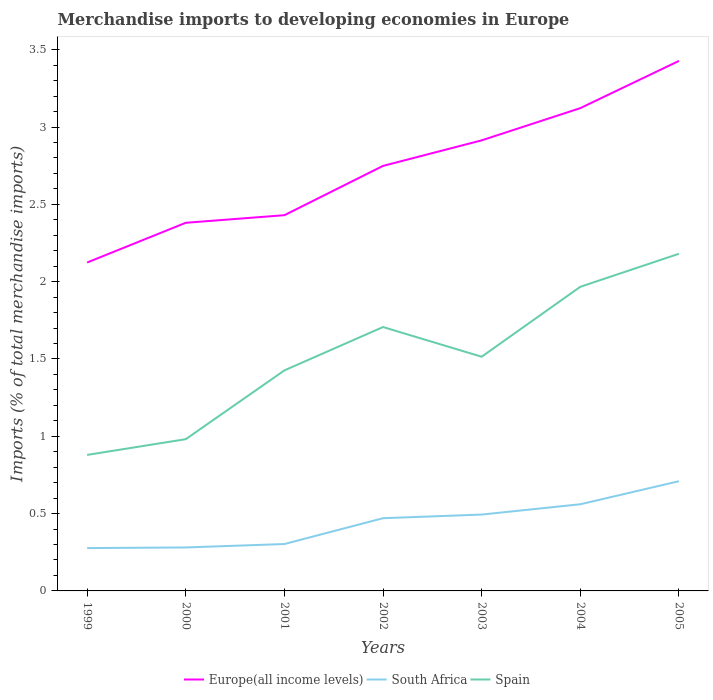How many different coloured lines are there?
Provide a short and direct response. 3. Across all years, what is the maximum percentage total merchandise imports in South Africa?
Your answer should be compact. 0.28. In which year was the percentage total merchandise imports in Spain maximum?
Give a very brief answer. 1999. What is the total percentage total merchandise imports in South Africa in the graph?
Keep it short and to the point. -0.15. What is the difference between the highest and the second highest percentage total merchandise imports in South Africa?
Give a very brief answer. 0.43. How many years are there in the graph?
Your answer should be very brief. 7. Does the graph contain any zero values?
Offer a terse response. No. Where does the legend appear in the graph?
Ensure brevity in your answer.  Bottom center. How many legend labels are there?
Provide a short and direct response. 3. What is the title of the graph?
Offer a terse response. Merchandise imports to developing economies in Europe. What is the label or title of the X-axis?
Give a very brief answer. Years. What is the label or title of the Y-axis?
Make the answer very short. Imports (% of total merchandise imports). What is the Imports (% of total merchandise imports) in Europe(all income levels) in 1999?
Your answer should be compact. 2.12. What is the Imports (% of total merchandise imports) of South Africa in 1999?
Provide a succinct answer. 0.28. What is the Imports (% of total merchandise imports) in Spain in 1999?
Your response must be concise. 0.88. What is the Imports (% of total merchandise imports) of Europe(all income levels) in 2000?
Your answer should be compact. 2.38. What is the Imports (% of total merchandise imports) in South Africa in 2000?
Offer a very short reply. 0.28. What is the Imports (% of total merchandise imports) in Spain in 2000?
Offer a very short reply. 0.98. What is the Imports (% of total merchandise imports) in Europe(all income levels) in 2001?
Give a very brief answer. 2.43. What is the Imports (% of total merchandise imports) of South Africa in 2001?
Keep it short and to the point. 0.3. What is the Imports (% of total merchandise imports) of Spain in 2001?
Keep it short and to the point. 1.43. What is the Imports (% of total merchandise imports) of Europe(all income levels) in 2002?
Your answer should be very brief. 2.75. What is the Imports (% of total merchandise imports) of South Africa in 2002?
Provide a succinct answer. 0.47. What is the Imports (% of total merchandise imports) in Spain in 2002?
Your answer should be very brief. 1.71. What is the Imports (% of total merchandise imports) of Europe(all income levels) in 2003?
Your response must be concise. 2.91. What is the Imports (% of total merchandise imports) in South Africa in 2003?
Provide a succinct answer. 0.49. What is the Imports (% of total merchandise imports) in Spain in 2003?
Your response must be concise. 1.51. What is the Imports (% of total merchandise imports) in Europe(all income levels) in 2004?
Offer a very short reply. 3.12. What is the Imports (% of total merchandise imports) of South Africa in 2004?
Your response must be concise. 0.56. What is the Imports (% of total merchandise imports) in Spain in 2004?
Keep it short and to the point. 1.97. What is the Imports (% of total merchandise imports) of Europe(all income levels) in 2005?
Make the answer very short. 3.43. What is the Imports (% of total merchandise imports) in South Africa in 2005?
Make the answer very short. 0.71. What is the Imports (% of total merchandise imports) of Spain in 2005?
Give a very brief answer. 2.18. Across all years, what is the maximum Imports (% of total merchandise imports) in Europe(all income levels)?
Keep it short and to the point. 3.43. Across all years, what is the maximum Imports (% of total merchandise imports) of South Africa?
Your answer should be compact. 0.71. Across all years, what is the maximum Imports (% of total merchandise imports) of Spain?
Your response must be concise. 2.18. Across all years, what is the minimum Imports (% of total merchandise imports) in Europe(all income levels)?
Provide a short and direct response. 2.12. Across all years, what is the minimum Imports (% of total merchandise imports) of South Africa?
Keep it short and to the point. 0.28. Across all years, what is the minimum Imports (% of total merchandise imports) of Spain?
Offer a terse response. 0.88. What is the total Imports (% of total merchandise imports) of Europe(all income levels) in the graph?
Provide a succinct answer. 19.15. What is the total Imports (% of total merchandise imports) in South Africa in the graph?
Your answer should be very brief. 3.1. What is the total Imports (% of total merchandise imports) of Spain in the graph?
Your answer should be compact. 10.66. What is the difference between the Imports (% of total merchandise imports) in Europe(all income levels) in 1999 and that in 2000?
Provide a short and direct response. -0.26. What is the difference between the Imports (% of total merchandise imports) in South Africa in 1999 and that in 2000?
Keep it short and to the point. -0. What is the difference between the Imports (% of total merchandise imports) of Spain in 1999 and that in 2000?
Offer a very short reply. -0.1. What is the difference between the Imports (% of total merchandise imports) of Europe(all income levels) in 1999 and that in 2001?
Give a very brief answer. -0.31. What is the difference between the Imports (% of total merchandise imports) of South Africa in 1999 and that in 2001?
Offer a terse response. -0.03. What is the difference between the Imports (% of total merchandise imports) in Spain in 1999 and that in 2001?
Your answer should be compact. -0.55. What is the difference between the Imports (% of total merchandise imports) in Europe(all income levels) in 1999 and that in 2002?
Make the answer very short. -0.62. What is the difference between the Imports (% of total merchandise imports) in South Africa in 1999 and that in 2002?
Your response must be concise. -0.19. What is the difference between the Imports (% of total merchandise imports) of Spain in 1999 and that in 2002?
Provide a short and direct response. -0.83. What is the difference between the Imports (% of total merchandise imports) of Europe(all income levels) in 1999 and that in 2003?
Make the answer very short. -0.79. What is the difference between the Imports (% of total merchandise imports) of South Africa in 1999 and that in 2003?
Keep it short and to the point. -0.22. What is the difference between the Imports (% of total merchandise imports) in Spain in 1999 and that in 2003?
Your response must be concise. -0.64. What is the difference between the Imports (% of total merchandise imports) in Europe(all income levels) in 1999 and that in 2004?
Keep it short and to the point. -1. What is the difference between the Imports (% of total merchandise imports) in South Africa in 1999 and that in 2004?
Ensure brevity in your answer.  -0.28. What is the difference between the Imports (% of total merchandise imports) in Spain in 1999 and that in 2004?
Provide a succinct answer. -1.09. What is the difference between the Imports (% of total merchandise imports) in Europe(all income levels) in 1999 and that in 2005?
Keep it short and to the point. -1.3. What is the difference between the Imports (% of total merchandise imports) in South Africa in 1999 and that in 2005?
Give a very brief answer. -0.43. What is the difference between the Imports (% of total merchandise imports) in Spain in 1999 and that in 2005?
Offer a terse response. -1.3. What is the difference between the Imports (% of total merchandise imports) of Europe(all income levels) in 2000 and that in 2001?
Provide a short and direct response. -0.05. What is the difference between the Imports (% of total merchandise imports) of South Africa in 2000 and that in 2001?
Your answer should be very brief. -0.02. What is the difference between the Imports (% of total merchandise imports) of Spain in 2000 and that in 2001?
Your response must be concise. -0.44. What is the difference between the Imports (% of total merchandise imports) in Europe(all income levels) in 2000 and that in 2002?
Offer a very short reply. -0.37. What is the difference between the Imports (% of total merchandise imports) of South Africa in 2000 and that in 2002?
Provide a short and direct response. -0.19. What is the difference between the Imports (% of total merchandise imports) of Spain in 2000 and that in 2002?
Your answer should be compact. -0.73. What is the difference between the Imports (% of total merchandise imports) of Europe(all income levels) in 2000 and that in 2003?
Make the answer very short. -0.53. What is the difference between the Imports (% of total merchandise imports) of South Africa in 2000 and that in 2003?
Your response must be concise. -0.21. What is the difference between the Imports (% of total merchandise imports) of Spain in 2000 and that in 2003?
Your answer should be compact. -0.53. What is the difference between the Imports (% of total merchandise imports) in Europe(all income levels) in 2000 and that in 2004?
Offer a terse response. -0.74. What is the difference between the Imports (% of total merchandise imports) of South Africa in 2000 and that in 2004?
Offer a terse response. -0.28. What is the difference between the Imports (% of total merchandise imports) in Spain in 2000 and that in 2004?
Your response must be concise. -0.99. What is the difference between the Imports (% of total merchandise imports) in Europe(all income levels) in 2000 and that in 2005?
Give a very brief answer. -1.05. What is the difference between the Imports (% of total merchandise imports) in South Africa in 2000 and that in 2005?
Give a very brief answer. -0.43. What is the difference between the Imports (% of total merchandise imports) in Spain in 2000 and that in 2005?
Your answer should be compact. -1.2. What is the difference between the Imports (% of total merchandise imports) in Europe(all income levels) in 2001 and that in 2002?
Offer a very short reply. -0.32. What is the difference between the Imports (% of total merchandise imports) in South Africa in 2001 and that in 2002?
Provide a short and direct response. -0.17. What is the difference between the Imports (% of total merchandise imports) in Spain in 2001 and that in 2002?
Make the answer very short. -0.28. What is the difference between the Imports (% of total merchandise imports) of Europe(all income levels) in 2001 and that in 2003?
Your answer should be compact. -0.48. What is the difference between the Imports (% of total merchandise imports) of South Africa in 2001 and that in 2003?
Your response must be concise. -0.19. What is the difference between the Imports (% of total merchandise imports) of Spain in 2001 and that in 2003?
Make the answer very short. -0.09. What is the difference between the Imports (% of total merchandise imports) of Europe(all income levels) in 2001 and that in 2004?
Provide a succinct answer. -0.69. What is the difference between the Imports (% of total merchandise imports) in South Africa in 2001 and that in 2004?
Provide a short and direct response. -0.26. What is the difference between the Imports (% of total merchandise imports) of Spain in 2001 and that in 2004?
Ensure brevity in your answer.  -0.54. What is the difference between the Imports (% of total merchandise imports) of Europe(all income levels) in 2001 and that in 2005?
Your answer should be very brief. -1. What is the difference between the Imports (% of total merchandise imports) of South Africa in 2001 and that in 2005?
Provide a short and direct response. -0.41. What is the difference between the Imports (% of total merchandise imports) in Spain in 2001 and that in 2005?
Keep it short and to the point. -0.75. What is the difference between the Imports (% of total merchandise imports) of Europe(all income levels) in 2002 and that in 2003?
Your answer should be very brief. -0.17. What is the difference between the Imports (% of total merchandise imports) in South Africa in 2002 and that in 2003?
Your response must be concise. -0.02. What is the difference between the Imports (% of total merchandise imports) of Spain in 2002 and that in 2003?
Offer a terse response. 0.19. What is the difference between the Imports (% of total merchandise imports) in Europe(all income levels) in 2002 and that in 2004?
Your response must be concise. -0.37. What is the difference between the Imports (% of total merchandise imports) in South Africa in 2002 and that in 2004?
Ensure brevity in your answer.  -0.09. What is the difference between the Imports (% of total merchandise imports) in Spain in 2002 and that in 2004?
Your answer should be compact. -0.26. What is the difference between the Imports (% of total merchandise imports) in Europe(all income levels) in 2002 and that in 2005?
Your response must be concise. -0.68. What is the difference between the Imports (% of total merchandise imports) in South Africa in 2002 and that in 2005?
Your response must be concise. -0.24. What is the difference between the Imports (% of total merchandise imports) in Spain in 2002 and that in 2005?
Your response must be concise. -0.47. What is the difference between the Imports (% of total merchandise imports) in Europe(all income levels) in 2003 and that in 2004?
Keep it short and to the point. -0.21. What is the difference between the Imports (% of total merchandise imports) in South Africa in 2003 and that in 2004?
Your response must be concise. -0.07. What is the difference between the Imports (% of total merchandise imports) in Spain in 2003 and that in 2004?
Your response must be concise. -0.45. What is the difference between the Imports (% of total merchandise imports) in Europe(all income levels) in 2003 and that in 2005?
Provide a short and direct response. -0.51. What is the difference between the Imports (% of total merchandise imports) of South Africa in 2003 and that in 2005?
Provide a short and direct response. -0.22. What is the difference between the Imports (% of total merchandise imports) in Spain in 2003 and that in 2005?
Make the answer very short. -0.67. What is the difference between the Imports (% of total merchandise imports) in Europe(all income levels) in 2004 and that in 2005?
Your response must be concise. -0.31. What is the difference between the Imports (% of total merchandise imports) of South Africa in 2004 and that in 2005?
Give a very brief answer. -0.15. What is the difference between the Imports (% of total merchandise imports) of Spain in 2004 and that in 2005?
Offer a very short reply. -0.21. What is the difference between the Imports (% of total merchandise imports) of Europe(all income levels) in 1999 and the Imports (% of total merchandise imports) of South Africa in 2000?
Your answer should be very brief. 1.84. What is the difference between the Imports (% of total merchandise imports) in Europe(all income levels) in 1999 and the Imports (% of total merchandise imports) in Spain in 2000?
Provide a short and direct response. 1.14. What is the difference between the Imports (% of total merchandise imports) of South Africa in 1999 and the Imports (% of total merchandise imports) of Spain in 2000?
Make the answer very short. -0.7. What is the difference between the Imports (% of total merchandise imports) of Europe(all income levels) in 1999 and the Imports (% of total merchandise imports) of South Africa in 2001?
Your response must be concise. 1.82. What is the difference between the Imports (% of total merchandise imports) of Europe(all income levels) in 1999 and the Imports (% of total merchandise imports) of Spain in 2001?
Provide a succinct answer. 0.7. What is the difference between the Imports (% of total merchandise imports) of South Africa in 1999 and the Imports (% of total merchandise imports) of Spain in 2001?
Ensure brevity in your answer.  -1.15. What is the difference between the Imports (% of total merchandise imports) in Europe(all income levels) in 1999 and the Imports (% of total merchandise imports) in South Africa in 2002?
Offer a very short reply. 1.65. What is the difference between the Imports (% of total merchandise imports) in Europe(all income levels) in 1999 and the Imports (% of total merchandise imports) in Spain in 2002?
Ensure brevity in your answer.  0.42. What is the difference between the Imports (% of total merchandise imports) in South Africa in 1999 and the Imports (% of total merchandise imports) in Spain in 2002?
Keep it short and to the point. -1.43. What is the difference between the Imports (% of total merchandise imports) of Europe(all income levels) in 1999 and the Imports (% of total merchandise imports) of South Africa in 2003?
Provide a short and direct response. 1.63. What is the difference between the Imports (% of total merchandise imports) in Europe(all income levels) in 1999 and the Imports (% of total merchandise imports) in Spain in 2003?
Offer a very short reply. 0.61. What is the difference between the Imports (% of total merchandise imports) in South Africa in 1999 and the Imports (% of total merchandise imports) in Spain in 2003?
Your answer should be compact. -1.24. What is the difference between the Imports (% of total merchandise imports) of Europe(all income levels) in 1999 and the Imports (% of total merchandise imports) of South Africa in 2004?
Provide a short and direct response. 1.56. What is the difference between the Imports (% of total merchandise imports) of Europe(all income levels) in 1999 and the Imports (% of total merchandise imports) of Spain in 2004?
Your response must be concise. 0.16. What is the difference between the Imports (% of total merchandise imports) in South Africa in 1999 and the Imports (% of total merchandise imports) in Spain in 2004?
Provide a succinct answer. -1.69. What is the difference between the Imports (% of total merchandise imports) in Europe(all income levels) in 1999 and the Imports (% of total merchandise imports) in South Africa in 2005?
Ensure brevity in your answer.  1.41. What is the difference between the Imports (% of total merchandise imports) of Europe(all income levels) in 1999 and the Imports (% of total merchandise imports) of Spain in 2005?
Provide a short and direct response. -0.06. What is the difference between the Imports (% of total merchandise imports) of South Africa in 1999 and the Imports (% of total merchandise imports) of Spain in 2005?
Provide a succinct answer. -1.9. What is the difference between the Imports (% of total merchandise imports) of Europe(all income levels) in 2000 and the Imports (% of total merchandise imports) of South Africa in 2001?
Keep it short and to the point. 2.08. What is the difference between the Imports (% of total merchandise imports) in Europe(all income levels) in 2000 and the Imports (% of total merchandise imports) in Spain in 2001?
Provide a succinct answer. 0.95. What is the difference between the Imports (% of total merchandise imports) in South Africa in 2000 and the Imports (% of total merchandise imports) in Spain in 2001?
Keep it short and to the point. -1.15. What is the difference between the Imports (% of total merchandise imports) in Europe(all income levels) in 2000 and the Imports (% of total merchandise imports) in South Africa in 2002?
Offer a terse response. 1.91. What is the difference between the Imports (% of total merchandise imports) in Europe(all income levels) in 2000 and the Imports (% of total merchandise imports) in Spain in 2002?
Keep it short and to the point. 0.67. What is the difference between the Imports (% of total merchandise imports) of South Africa in 2000 and the Imports (% of total merchandise imports) of Spain in 2002?
Give a very brief answer. -1.43. What is the difference between the Imports (% of total merchandise imports) in Europe(all income levels) in 2000 and the Imports (% of total merchandise imports) in South Africa in 2003?
Your answer should be compact. 1.89. What is the difference between the Imports (% of total merchandise imports) of Europe(all income levels) in 2000 and the Imports (% of total merchandise imports) of Spain in 2003?
Keep it short and to the point. 0.87. What is the difference between the Imports (% of total merchandise imports) of South Africa in 2000 and the Imports (% of total merchandise imports) of Spain in 2003?
Provide a short and direct response. -1.23. What is the difference between the Imports (% of total merchandise imports) in Europe(all income levels) in 2000 and the Imports (% of total merchandise imports) in South Africa in 2004?
Ensure brevity in your answer.  1.82. What is the difference between the Imports (% of total merchandise imports) in Europe(all income levels) in 2000 and the Imports (% of total merchandise imports) in Spain in 2004?
Your answer should be very brief. 0.41. What is the difference between the Imports (% of total merchandise imports) in South Africa in 2000 and the Imports (% of total merchandise imports) in Spain in 2004?
Offer a terse response. -1.69. What is the difference between the Imports (% of total merchandise imports) in Europe(all income levels) in 2000 and the Imports (% of total merchandise imports) in South Africa in 2005?
Ensure brevity in your answer.  1.67. What is the difference between the Imports (% of total merchandise imports) in Europe(all income levels) in 2000 and the Imports (% of total merchandise imports) in Spain in 2005?
Offer a terse response. 0.2. What is the difference between the Imports (% of total merchandise imports) in South Africa in 2000 and the Imports (% of total merchandise imports) in Spain in 2005?
Make the answer very short. -1.9. What is the difference between the Imports (% of total merchandise imports) in Europe(all income levels) in 2001 and the Imports (% of total merchandise imports) in South Africa in 2002?
Your answer should be very brief. 1.96. What is the difference between the Imports (% of total merchandise imports) in Europe(all income levels) in 2001 and the Imports (% of total merchandise imports) in Spain in 2002?
Offer a very short reply. 0.72. What is the difference between the Imports (% of total merchandise imports) of South Africa in 2001 and the Imports (% of total merchandise imports) of Spain in 2002?
Give a very brief answer. -1.4. What is the difference between the Imports (% of total merchandise imports) of Europe(all income levels) in 2001 and the Imports (% of total merchandise imports) of South Africa in 2003?
Ensure brevity in your answer.  1.94. What is the difference between the Imports (% of total merchandise imports) in Europe(all income levels) in 2001 and the Imports (% of total merchandise imports) in Spain in 2003?
Your response must be concise. 0.92. What is the difference between the Imports (% of total merchandise imports) of South Africa in 2001 and the Imports (% of total merchandise imports) of Spain in 2003?
Make the answer very short. -1.21. What is the difference between the Imports (% of total merchandise imports) of Europe(all income levels) in 2001 and the Imports (% of total merchandise imports) of South Africa in 2004?
Your response must be concise. 1.87. What is the difference between the Imports (% of total merchandise imports) in Europe(all income levels) in 2001 and the Imports (% of total merchandise imports) in Spain in 2004?
Offer a terse response. 0.46. What is the difference between the Imports (% of total merchandise imports) of South Africa in 2001 and the Imports (% of total merchandise imports) of Spain in 2004?
Make the answer very short. -1.66. What is the difference between the Imports (% of total merchandise imports) in Europe(all income levels) in 2001 and the Imports (% of total merchandise imports) in South Africa in 2005?
Offer a very short reply. 1.72. What is the difference between the Imports (% of total merchandise imports) in Europe(all income levels) in 2001 and the Imports (% of total merchandise imports) in Spain in 2005?
Give a very brief answer. 0.25. What is the difference between the Imports (% of total merchandise imports) of South Africa in 2001 and the Imports (% of total merchandise imports) of Spain in 2005?
Your answer should be very brief. -1.88. What is the difference between the Imports (% of total merchandise imports) of Europe(all income levels) in 2002 and the Imports (% of total merchandise imports) of South Africa in 2003?
Your answer should be very brief. 2.25. What is the difference between the Imports (% of total merchandise imports) of Europe(all income levels) in 2002 and the Imports (% of total merchandise imports) of Spain in 2003?
Offer a very short reply. 1.23. What is the difference between the Imports (% of total merchandise imports) in South Africa in 2002 and the Imports (% of total merchandise imports) in Spain in 2003?
Your answer should be very brief. -1.04. What is the difference between the Imports (% of total merchandise imports) of Europe(all income levels) in 2002 and the Imports (% of total merchandise imports) of South Africa in 2004?
Offer a very short reply. 2.19. What is the difference between the Imports (% of total merchandise imports) of Europe(all income levels) in 2002 and the Imports (% of total merchandise imports) of Spain in 2004?
Provide a short and direct response. 0.78. What is the difference between the Imports (% of total merchandise imports) in South Africa in 2002 and the Imports (% of total merchandise imports) in Spain in 2004?
Offer a very short reply. -1.5. What is the difference between the Imports (% of total merchandise imports) in Europe(all income levels) in 2002 and the Imports (% of total merchandise imports) in South Africa in 2005?
Keep it short and to the point. 2.04. What is the difference between the Imports (% of total merchandise imports) of Europe(all income levels) in 2002 and the Imports (% of total merchandise imports) of Spain in 2005?
Offer a terse response. 0.57. What is the difference between the Imports (% of total merchandise imports) of South Africa in 2002 and the Imports (% of total merchandise imports) of Spain in 2005?
Provide a succinct answer. -1.71. What is the difference between the Imports (% of total merchandise imports) in Europe(all income levels) in 2003 and the Imports (% of total merchandise imports) in South Africa in 2004?
Make the answer very short. 2.35. What is the difference between the Imports (% of total merchandise imports) in Europe(all income levels) in 2003 and the Imports (% of total merchandise imports) in Spain in 2004?
Make the answer very short. 0.95. What is the difference between the Imports (% of total merchandise imports) of South Africa in 2003 and the Imports (% of total merchandise imports) of Spain in 2004?
Ensure brevity in your answer.  -1.47. What is the difference between the Imports (% of total merchandise imports) of Europe(all income levels) in 2003 and the Imports (% of total merchandise imports) of South Africa in 2005?
Keep it short and to the point. 2.2. What is the difference between the Imports (% of total merchandise imports) in Europe(all income levels) in 2003 and the Imports (% of total merchandise imports) in Spain in 2005?
Make the answer very short. 0.73. What is the difference between the Imports (% of total merchandise imports) of South Africa in 2003 and the Imports (% of total merchandise imports) of Spain in 2005?
Make the answer very short. -1.69. What is the difference between the Imports (% of total merchandise imports) in Europe(all income levels) in 2004 and the Imports (% of total merchandise imports) in South Africa in 2005?
Keep it short and to the point. 2.41. What is the difference between the Imports (% of total merchandise imports) of Europe(all income levels) in 2004 and the Imports (% of total merchandise imports) of Spain in 2005?
Keep it short and to the point. 0.94. What is the difference between the Imports (% of total merchandise imports) in South Africa in 2004 and the Imports (% of total merchandise imports) in Spain in 2005?
Provide a succinct answer. -1.62. What is the average Imports (% of total merchandise imports) in Europe(all income levels) per year?
Provide a short and direct response. 2.74. What is the average Imports (% of total merchandise imports) in South Africa per year?
Give a very brief answer. 0.44. What is the average Imports (% of total merchandise imports) in Spain per year?
Offer a terse response. 1.52. In the year 1999, what is the difference between the Imports (% of total merchandise imports) of Europe(all income levels) and Imports (% of total merchandise imports) of South Africa?
Make the answer very short. 1.85. In the year 1999, what is the difference between the Imports (% of total merchandise imports) of Europe(all income levels) and Imports (% of total merchandise imports) of Spain?
Make the answer very short. 1.24. In the year 1999, what is the difference between the Imports (% of total merchandise imports) of South Africa and Imports (% of total merchandise imports) of Spain?
Your response must be concise. -0.6. In the year 2000, what is the difference between the Imports (% of total merchandise imports) of Europe(all income levels) and Imports (% of total merchandise imports) of South Africa?
Keep it short and to the point. 2.1. In the year 2000, what is the difference between the Imports (% of total merchandise imports) of Europe(all income levels) and Imports (% of total merchandise imports) of Spain?
Provide a short and direct response. 1.4. In the year 2000, what is the difference between the Imports (% of total merchandise imports) in South Africa and Imports (% of total merchandise imports) in Spain?
Make the answer very short. -0.7. In the year 2001, what is the difference between the Imports (% of total merchandise imports) in Europe(all income levels) and Imports (% of total merchandise imports) in South Africa?
Keep it short and to the point. 2.13. In the year 2001, what is the difference between the Imports (% of total merchandise imports) in Europe(all income levels) and Imports (% of total merchandise imports) in Spain?
Keep it short and to the point. 1. In the year 2001, what is the difference between the Imports (% of total merchandise imports) of South Africa and Imports (% of total merchandise imports) of Spain?
Your response must be concise. -1.12. In the year 2002, what is the difference between the Imports (% of total merchandise imports) of Europe(all income levels) and Imports (% of total merchandise imports) of South Africa?
Your response must be concise. 2.28. In the year 2002, what is the difference between the Imports (% of total merchandise imports) of Europe(all income levels) and Imports (% of total merchandise imports) of Spain?
Offer a terse response. 1.04. In the year 2002, what is the difference between the Imports (% of total merchandise imports) in South Africa and Imports (% of total merchandise imports) in Spain?
Give a very brief answer. -1.24. In the year 2003, what is the difference between the Imports (% of total merchandise imports) in Europe(all income levels) and Imports (% of total merchandise imports) in South Africa?
Your answer should be very brief. 2.42. In the year 2003, what is the difference between the Imports (% of total merchandise imports) in Europe(all income levels) and Imports (% of total merchandise imports) in Spain?
Offer a very short reply. 1.4. In the year 2003, what is the difference between the Imports (% of total merchandise imports) in South Africa and Imports (% of total merchandise imports) in Spain?
Offer a very short reply. -1.02. In the year 2004, what is the difference between the Imports (% of total merchandise imports) in Europe(all income levels) and Imports (% of total merchandise imports) in South Africa?
Keep it short and to the point. 2.56. In the year 2004, what is the difference between the Imports (% of total merchandise imports) of Europe(all income levels) and Imports (% of total merchandise imports) of Spain?
Your answer should be compact. 1.16. In the year 2004, what is the difference between the Imports (% of total merchandise imports) in South Africa and Imports (% of total merchandise imports) in Spain?
Ensure brevity in your answer.  -1.41. In the year 2005, what is the difference between the Imports (% of total merchandise imports) in Europe(all income levels) and Imports (% of total merchandise imports) in South Africa?
Your answer should be compact. 2.72. In the year 2005, what is the difference between the Imports (% of total merchandise imports) of Europe(all income levels) and Imports (% of total merchandise imports) of Spain?
Your answer should be compact. 1.25. In the year 2005, what is the difference between the Imports (% of total merchandise imports) of South Africa and Imports (% of total merchandise imports) of Spain?
Provide a short and direct response. -1.47. What is the ratio of the Imports (% of total merchandise imports) in Europe(all income levels) in 1999 to that in 2000?
Ensure brevity in your answer.  0.89. What is the ratio of the Imports (% of total merchandise imports) in South Africa in 1999 to that in 2000?
Ensure brevity in your answer.  0.99. What is the ratio of the Imports (% of total merchandise imports) of Spain in 1999 to that in 2000?
Offer a very short reply. 0.9. What is the ratio of the Imports (% of total merchandise imports) of Europe(all income levels) in 1999 to that in 2001?
Provide a short and direct response. 0.87. What is the ratio of the Imports (% of total merchandise imports) in South Africa in 1999 to that in 2001?
Your response must be concise. 0.91. What is the ratio of the Imports (% of total merchandise imports) of Spain in 1999 to that in 2001?
Your answer should be compact. 0.62. What is the ratio of the Imports (% of total merchandise imports) of Europe(all income levels) in 1999 to that in 2002?
Your answer should be very brief. 0.77. What is the ratio of the Imports (% of total merchandise imports) in South Africa in 1999 to that in 2002?
Offer a terse response. 0.59. What is the ratio of the Imports (% of total merchandise imports) in Spain in 1999 to that in 2002?
Keep it short and to the point. 0.52. What is the ratio of the Imports (% of total merchandise imports) of Europe(all income levels) in 1999 to that in 2003?
Offer a very short reply. 0.73. What is the ratio of the Imports (% of total merchandise imports) in South Africa in 1999 to that in 2003?
Your answer should be very brief. 0.56. What is the ratio of the Imports (% of total merchandise imports) of Spain in 1999 to that in 2003?
Offer a terse response. 0.58. What is the ratio of the Imports (% of total merchandise imports) of Europe(all income levels) in 1999 to that in 2004?
Your answer should be compact. 0.68. What is the ratio of the Imports (% of total merchandise imports) of South Africa in 1999 to that in 2004?
Provide a short and direct response. 0.49. What is the ratio of the Imports (% of total merchandise imports) of Spain in 1999 to that in 2004?
Make the answer very short. 0.45. What is the ratio of the Imports (% of total merchandise imports) in Europe(all income levels) in 1999 to that in 2005?
Your response must be concise. 0.62. What is the ratio of the Imports (% of total merchandise imports) in South Africa in 1999 to that in 2005?
Provide a short and direct response. 0.39. What is the ratio of the Imports (% of total merchandise imports) of Spain in 1999 to that in 2005?
Your response must be concise. 0.4. What is the ratio of the Imports (% of total merchandise imports) in Europe(all income levels) in 2000 to that in 2001?
Keep it short and to the point. 0.98. What is the ratio of the Imports (% of total merchandise imports) of South Africa in 2000 to that in 2001?
Offer a very short reply. 0.93. What is the ratio of the Imports (% of total merchandise imports) of Spain in 2000 to that in 2001?
Offer a very short reply. 0.69. What is the ratio of the Imports (% of total merchandise imports) in Europe(all income levels) in 2000 to that in 2002?
Make the answer very short. 0.87. What is the ratio of the Imports (% of total merchandise imports) of South Africa in 2000 to that in 2002?
Offer a terse response. 0.6. What is the ratio of the Imports (% of total merchandise imports) in Spain in 2000 to that in 2002?
Your answer should be very brief. 0.57. What is the ratio of the Imports (% of total merchandise imports) of Europe(all income levels) in 2000 to that in 2003?
Offer a terse response. 0.82. What is the ratio of the Imports (% of total merchandise imports) of South Africa in 2000 to that in 2003?
Make the answer very short. 0.57. What is the ratio of the Imports (% of total merchandise imports) in Spain in 2000 to that in 2003?
Your answer should be very brief. 0.65. What is the ratio of the Imports (% of total merchandise imports) in Europe(all income levels) in 2000 to that in 2004?
Your response must be concise. 0.76. What is the ratio of the Imports (% of total merchandise imports) in South Africa in 2000 to that in 2004?
Your response must be concise. 0.5. What is the ratio of the Imports (% of total merchandise imports) of Spain in 2000 to that in 2004?
Offer a very short reply. 0.5. What is the ratio of the Imports (% of total merchandise imports) in Europe(all income levels) in 2000 to that in 2005?
Give a very brief answer. 0.69. What is the ratio of the Imports (% of total merchandise imports) of South Africa in 2000 to that in 2005?
Offer a very short reply. 0.4. What is the ratio of the Imports (% of total merchandise imports) in Spain in 2000 to that in 2005?
Keep it short and to the point. 0.45. What is the ratio of the Imports (% of total merchandise imports) in Europe(all income levels) in 2001 to that in 2002?
Your response must be concise. 0.88. What is the ratio of the Imports (% of total merchandise imports) in South Africa in 2001 to that in 2002?
Ensure brevity in your answer.  0.64. What is the ratio of the Imports (% of total merchandise imports) in Spain in 2001 to that in 2002?
Provide a succinct answer. 0.84. What is the ratio of the Imports (% of total merchandise imports) of Europe(all income levels) in 2001 to that in 2003?
Offer a terse response. 0.83. What is the ratio of the Imports (% of total merchandise imports) in South Africa in 2001 to that in 2003?
Your response must be concise. 0.61. What is the ratio of the Imports (% of total merchandise imports) of Spain in 2001 to that in 2003?
Offer a terse response. 0.94. What is the ratio of the Imports (% of total merchandise imports) in Europe(all income levels) in 2001 to that in 2004?
Your answer should be compact. 0.78. What is the ratio of the Imports (% of total merchandise imports) in South Africa in 2001 to that in 2004?
Ensure brevity in your answer.  0.54. What is the ratio of the Imports (% of total merchandise imports) of Spain in 2001 to that in 2004?
Provide a short and direct response. 0.73. What is the ratio of the Imports (% of total merchandise imports) in Europe(all income levels) in 2001 to that in 2005?
Keep it short and to the point. 0.71. What is the ratio of the Imports (% of total merchandise imports) in South Africa in 2001 to that in 2005?
Your response must be concise. 0.43. What is the ratio of the Imports (% of total merchandise imports) of Spain in 2001 to that in 2005?
Your response must be concise. 0.65. What is the ratio of the Imports (% of total merchandise imports) in Europe(all income levels) in 2002 to that in 2003?
Make the answer very short. 0.94. What is the ratio of the Imports (% of total merchandise imports) in South Africa in 2002 to that in 2003?
Ensure brevity in your answer.  0.95. What is the ratio of the Imports (% of total merchandise imports) in Spain in 2002 to that in 2003?
Your answer should be compact. 1.13. What is the ratio of the Imports (% of total merchandise imports) in Europe(all income levels) in 2002 to that in 2004?
Provide a succinct answer. 0.88. What is the ratio of the Imports (% of total merchandise imports) in South Africa in 2002 to that in 2004?
Your response must be concise. 0.84. What is the ratio of the Imports (% of total merchandise imports) in Spain in 2002 to that in 2004?
Ensure brevity in your answer.  0.87. What is the ratio of the Imports (% of total merchandise imports) of Europe(all income levels) in 2002 to that in 2005?
Your response must be concise. 0.8. What is the ratio of the Imports (% of total merchandise imports) of South Africa in 2002 to that in 2005?
Give a very brief answer. 0.66. What is the ratio of the Imports (% of total merchandise imports) in Spain in 2002 to that in 2005?
Your answer should be compact. 0.78. What is the ratio of the Imports (% of total merchandise imports) of Europe(all income levels) in 2003 to that in 2004?
Ensure brevity in your answer.  0.93. What is the ratio of the Imports (% of total merchandise imports) of South Africa in 2003 to that in 2004?
Give a very brief answer. 0.88. What is the ratio of the Imports (% of total merchandise imports) of Spain in 2003 to that in 2004?
Offer a terse response. 0.77. What is the ratio of the Imports (% of total merchandise imports) of Europe(all income levels) in 2003 to that in 2005?
Offer a very short reply. 0.85. What is the ratio of the Imports (% of total merchandise imports) in South Africa in 2003 to that in 2005?
Provide a succinct answer. 0.7. What is the ratio of the Imports (% of total merchandise imports) of Spain in 2003 to that in 2005?
Give a very brief answer. 0.69. What is the ratio of the Imports (% of total merchandise imports) of Europe(all income levels) in 2004 to that in 2005?
Give a very brief answer. 0.91. What is the ratio of the Imports (% of total merchandise imports) in South Africa in 2004 to that in 2005?
Make the answer very short. 0.79. What is the ratio of the Imports (% of total merchandise imports) in Spain in 2004 to that in 2005?
Keep it short and to the point. 0.9. What is the difference between the highest and the second highest Imports (% of total merchandise imports) of Europe(all income levels)?
Your answer should be compact. 0.31. What is the difference between the highest and the second highest Imports (% of total merchandise imports) of South Africa?
Offer a terse response. 0.15. What is the difference between the highest and the second highest Imports (% of total merchandise imports) in Spain?
Provide a succinct answer. 0.21. What is the difference between the highest and the lowest Imports (% of total merchandise imports) in Europe(all income levels)?
Offer a terse response. 1.3. What is the difference between the highest and the lowest Imports (% of total merchandise imports) in South Africa?
Provide a succinct answer. 0.43. What is the difference between the highest and the lowest Imports (% of total merchandise imports) of Spain?
Offer a terse response. 1.3. 